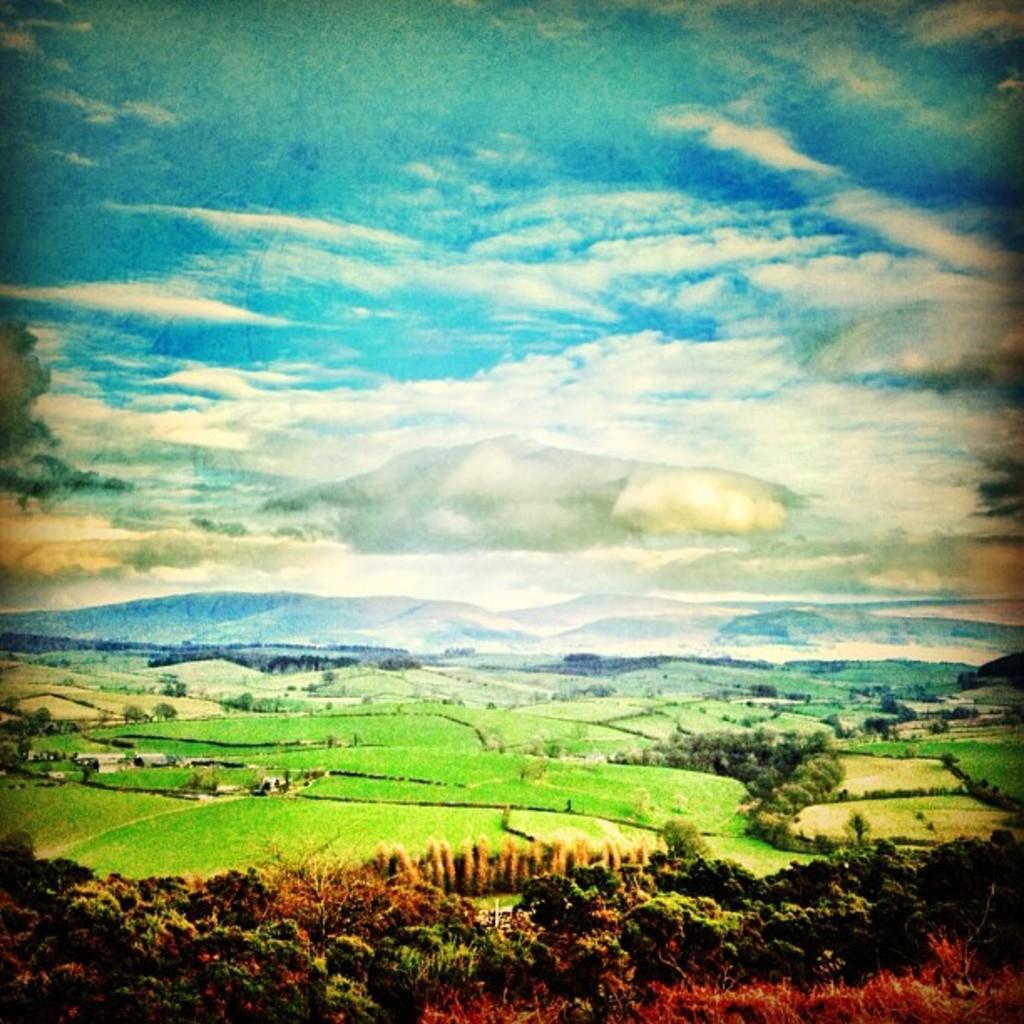Could you give a brief overview of what you see in this image? There are trees at the bottom of this image. We can see a grassy land and mountains in the background. The cloudy sky is at the top of this image. 